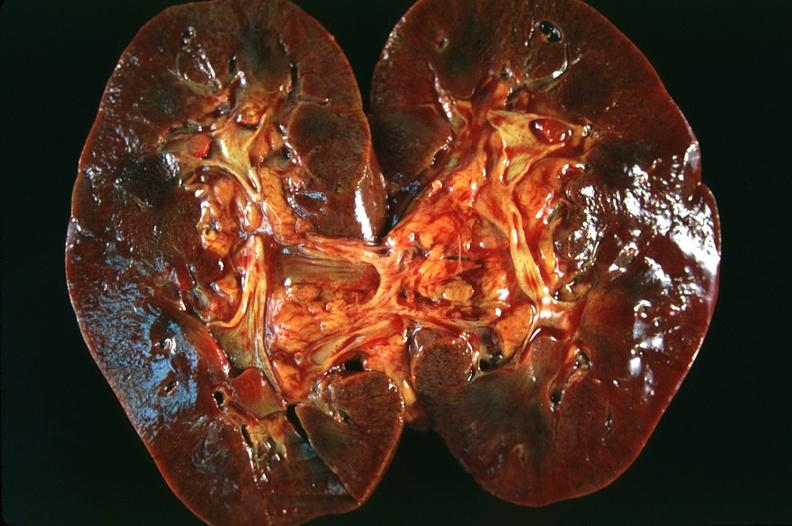does this image show kidney, congestion and blurring of the corticomedullary junction?
Answer the question using a single word or phrase. Yes 